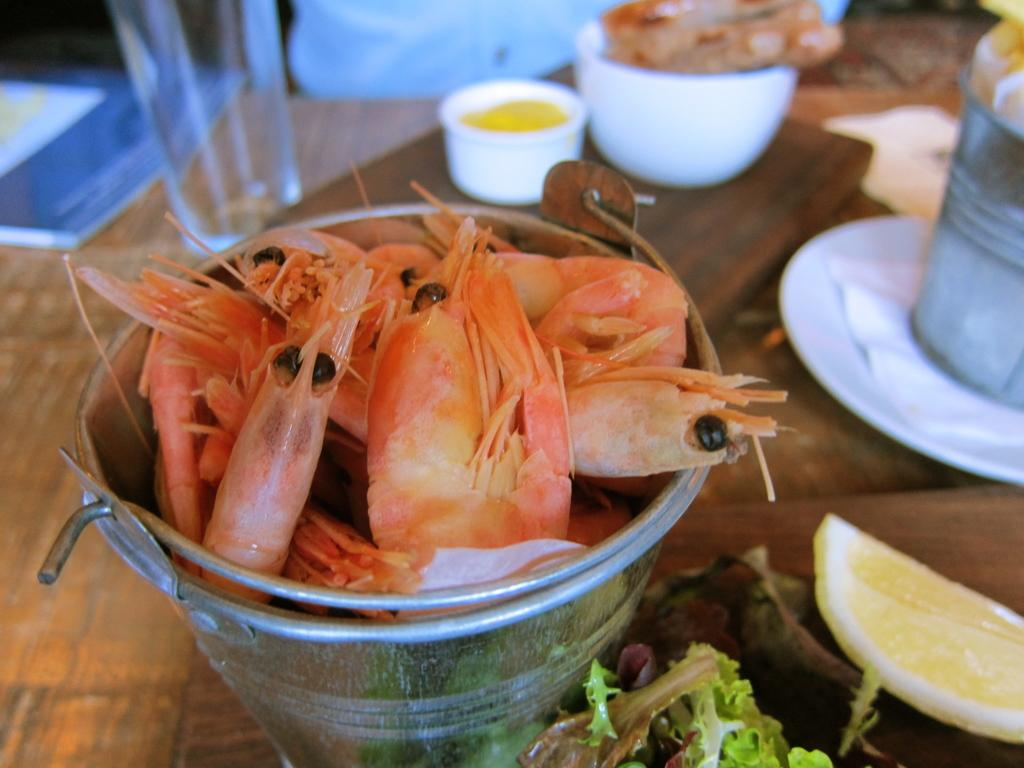What type of food is in the metal bucket in the image? There is seafood in a metal bucket in the image. What else can be seen near the metal bucket? There are objects near the metal bucket. What type of drink container is in the image? There is a water glass in the image. What type of dish is in the image? There is a food item in a bowl in the image. What type of table is in the image? There is a wooden table in the image. What grade of water is in the glass in the image? There is no indication of the water's grade in the image; it is simply a water glass. 